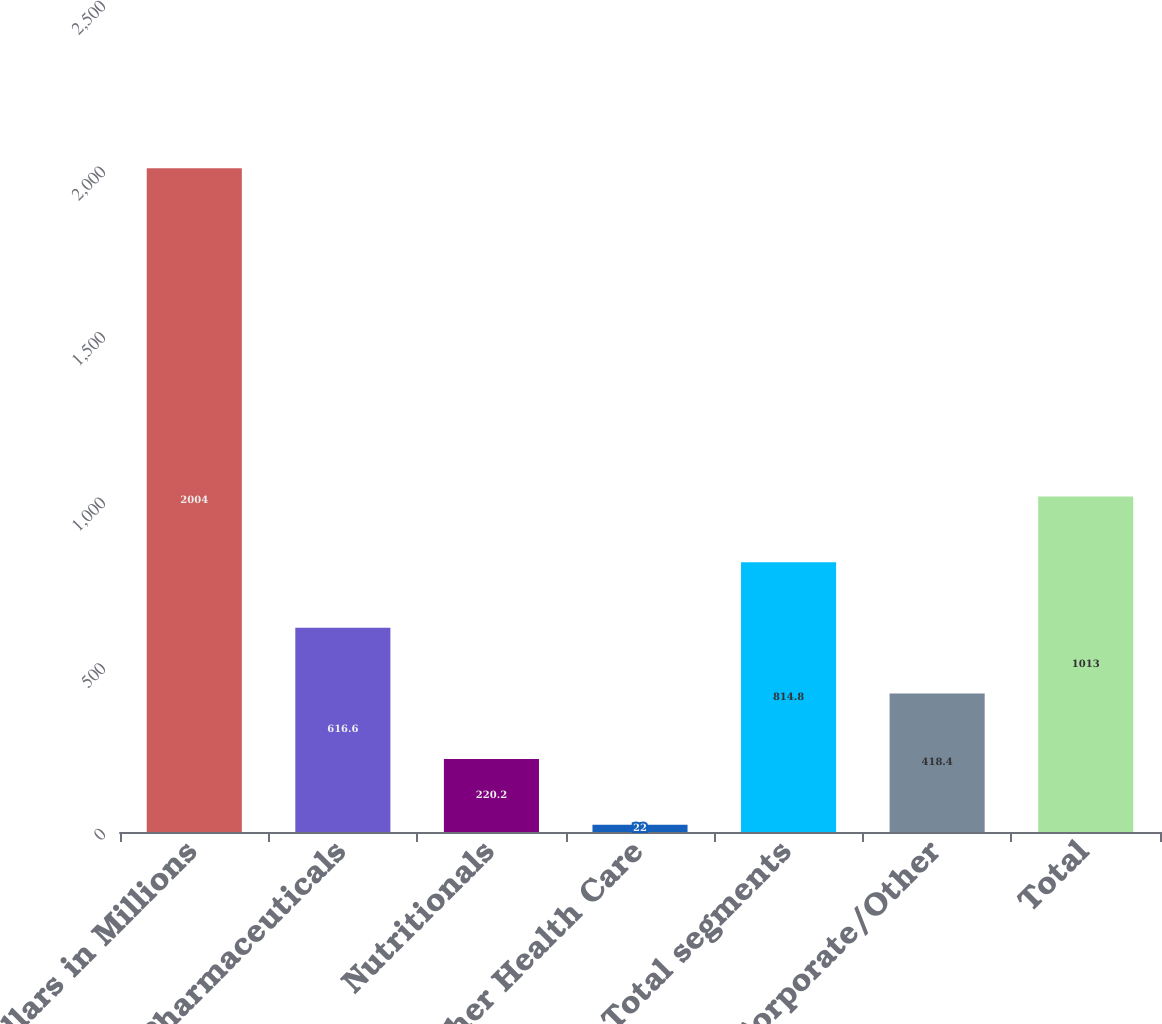Convert chart to OTSL. <chart><loc_0><loc_0><loc_500><loc_500><bar_chart><fcel>Dollars in Millions<fcel>Pharmaceuticals<fcel>Nutritionals<fcel>Other Health Care<fcel>Total segments<fcel>Corporate/Other<fcel>Total<nl><fcel>2004<fcel>616.6<fcel>220.2<fcel>22<fcel>814.8<fcel>418.4<fcel>1013<nl></chart> 